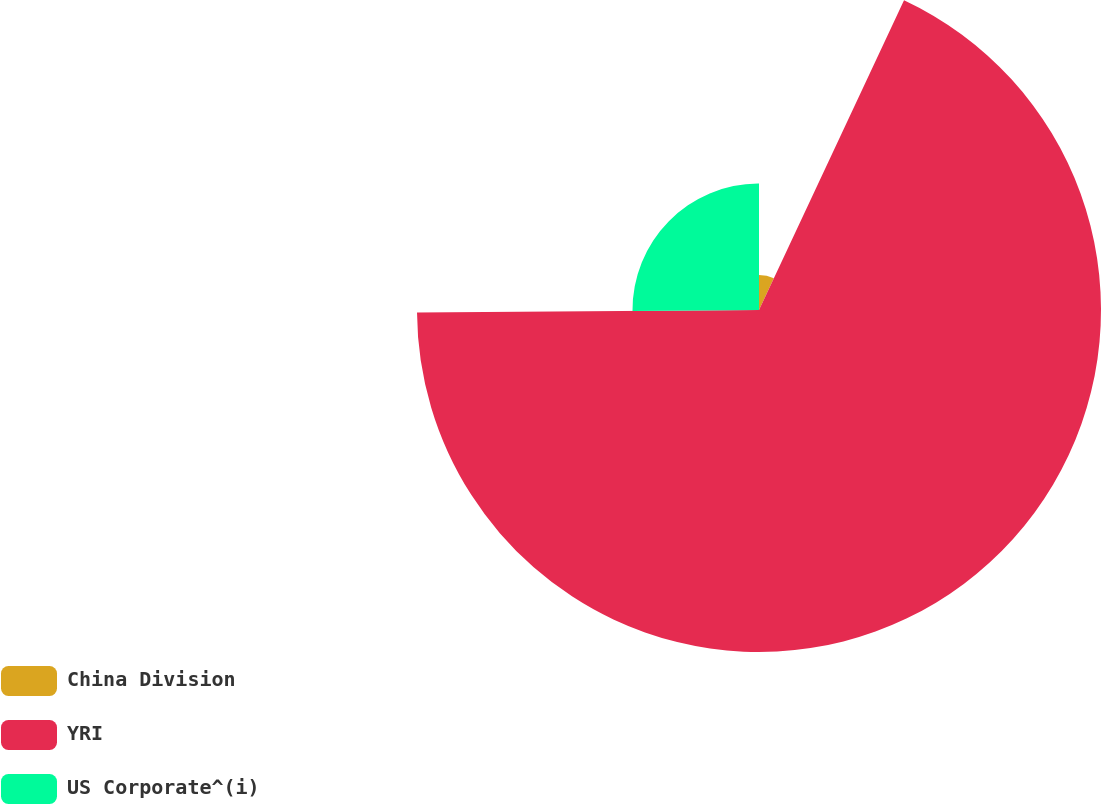Convert chart to OTSL. <chart><loc_0><loc_0><loc_500><loc_500><pie_chart><fcel>China Division<fcel>YRI<fcel>US Corporate^(i)<nl><fcel>6.97%<fcel>67.91%<fcel>25.12%<nl></chart> 